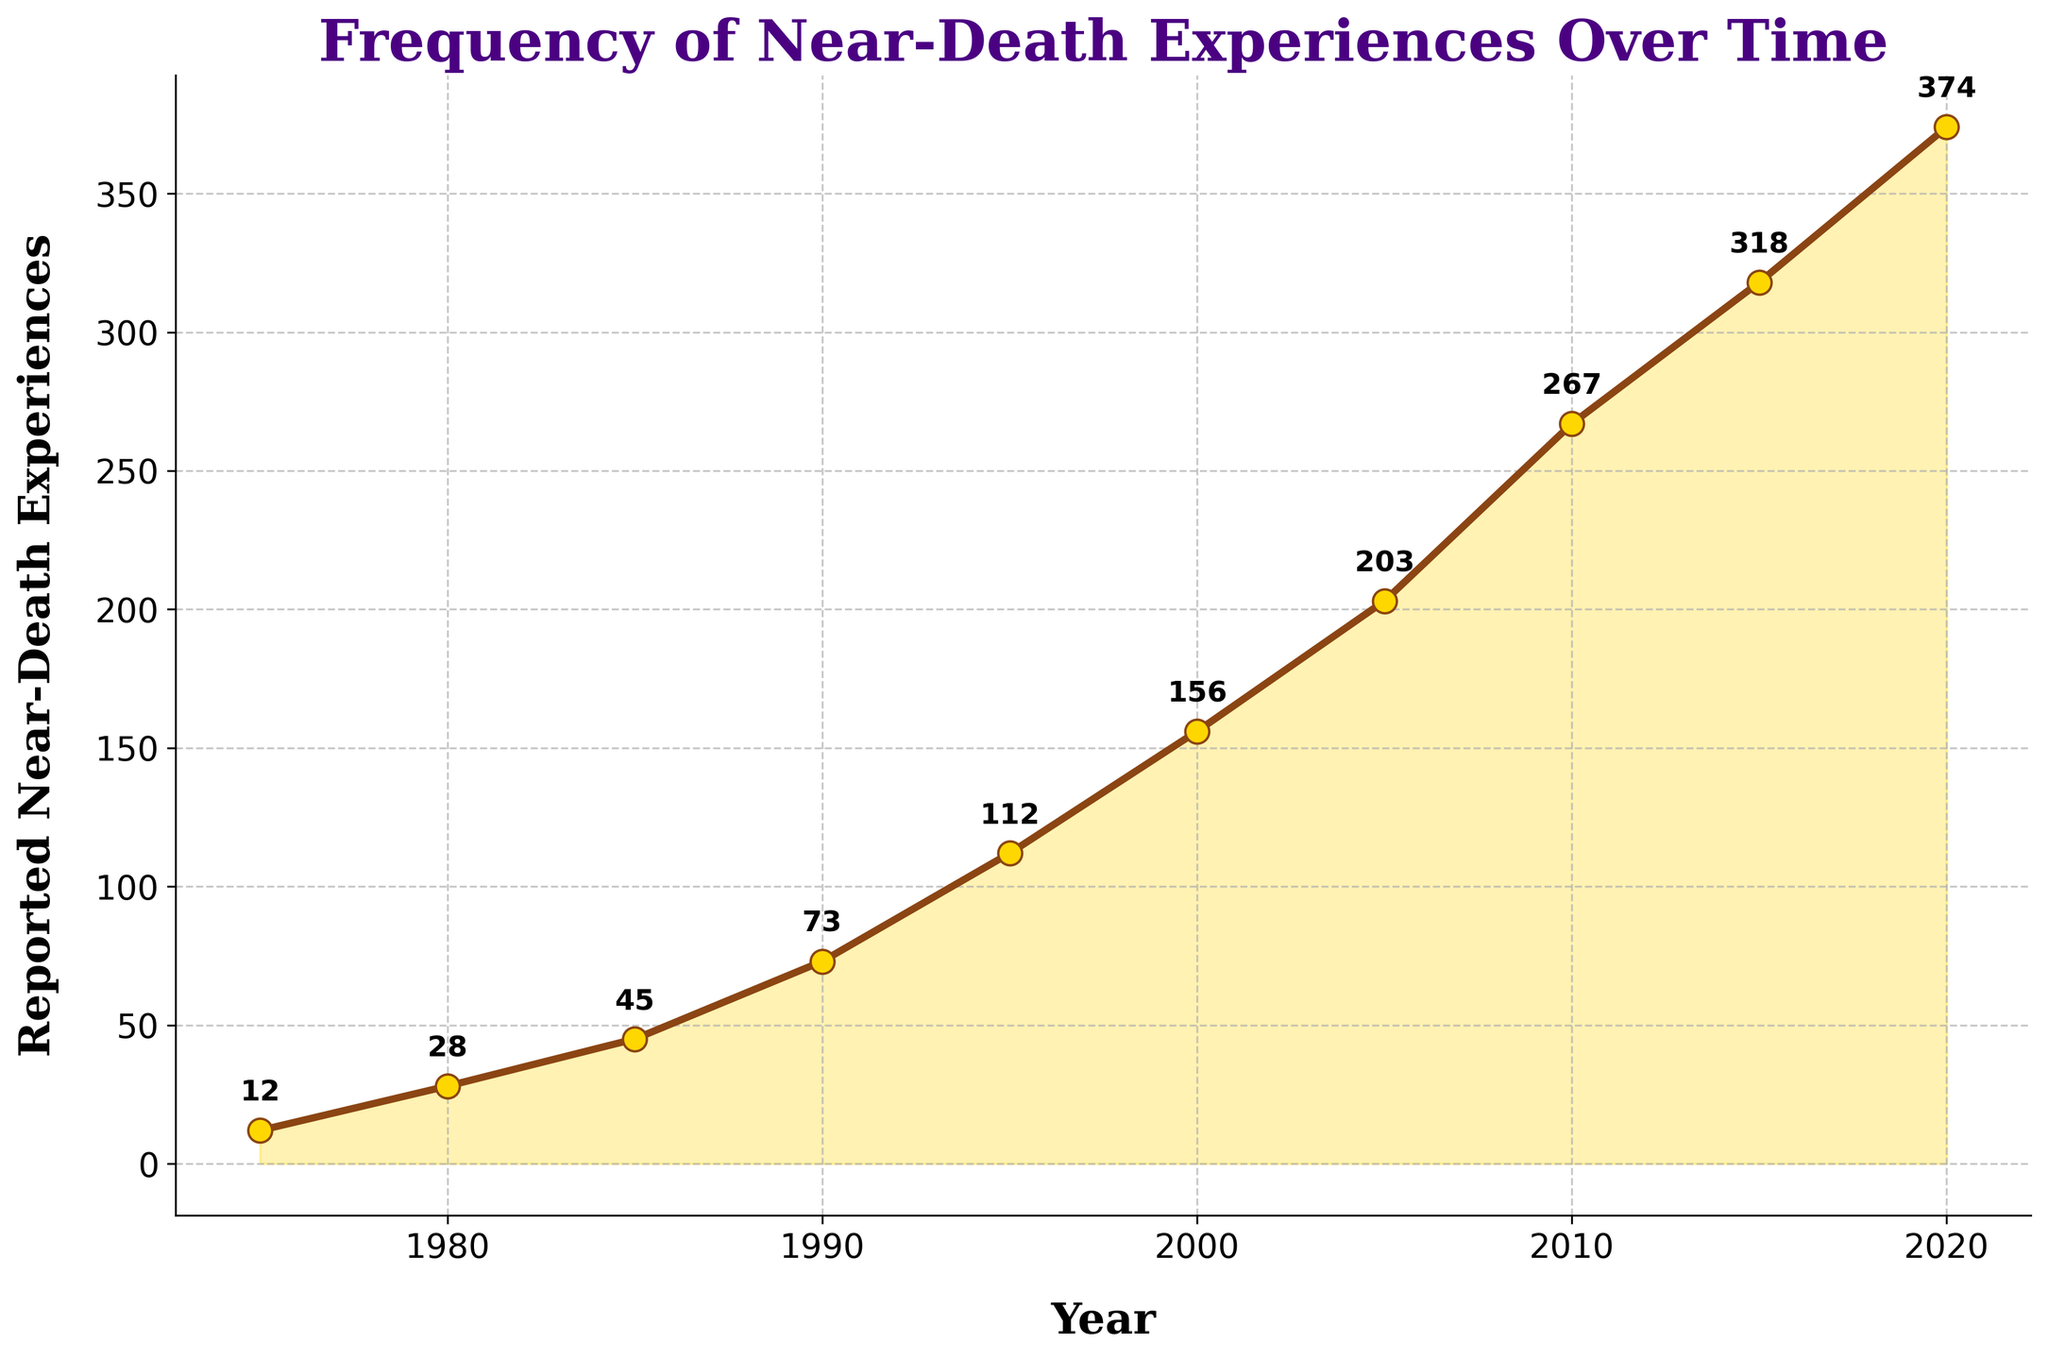What year saw the greatest increase in reported near-death experiences compared to the previous period? We can determine this by calculating the difference in reported experiences between each consecutive period. The differences are: 1975 to 1980 (16), 1980 to 1985 (17), 1985 to 1990 (28), 1990 to 1995 (39), 1995 to 2000 (44), 2000 to 2005 (47), 2005 to 2010 (64), 2010 to 2015 (51), 2015 to 2020 (56). The greatest increase is from 2005 to 2010 with an increase of 64.
Answer: 2010 What is the average number of reported near-death experiences per year from 1975 to 2020? Sum the total reported experiences and divide by the number of years. Total is 12 + 28 + 45 + 73 + 112 + 156 + 203 + 267 + 318 + 374 = 1588. There are 10 years, so the average is 1588 / 10.
Answer: 158.8 Between 2000 and 2020, in which period did the number of reported near-death experiences grow faster on average? From 2000 to 2005, the number increased by 47 (203 - 156), and this period covers 5 years, so the average annual increase is 47 / 5 = 9.4. From 2005 to 2010, it increased by 64, so the average annual increase is 64 / 5 = 12.8. From 2010 to 2015, it increased by 51, so the average annual increase is 51 / 5 = 10.2. Finally, from 2015 to 2020, the increase was 56, making the average annual increase 56 / 5 = 11.2. The period from 2005 to 2010 saw the fastest growth.
Answer: 2005-2010 How does the growth rate from 1980 to 1990 compare to the growth rate from 1990 to 2000? Calculate the yearly growth rates for each period and compare. From 1980 to 1990, grow is 73 - 28 = 45 over 10 years, so the average annual growth rate is 45 / 10 = 4.5. From 1990 to 2000, the growth is 156 - 73 = 83, so the average annual growth rate is 83 / 10 = 8.3. The growth rate from 1990 to 2000 is higher.
Answer: 1990-2000 What color is used to highlight the area under the line in the plot? The figure uses a distinct color to highlight the area under the line connected by the markers. The color used for this fill area is golden.
Answer: Golden What is the total number of reported near-death experiences from 1975 to 1995? Add up the reported numbers from 1975 to 1995. The sum is 12 + 28 + 45 + 73 + 112 = 270.
Answer: 270 Analyze the trend from 1975 to 2020. Does the frequency of reported near-death experiences show a steady increase, sporadic changes or a different pattern? By observing the line's continuity and upward progression, it is evident the frequency of near-death experiences shows a consistent and steady increase throughout the years, with no significant sporadic changes or erratic patterns seen.
Answer: Steady increase Which year marks the crossing of 100 reported near-death experiences for the first time? Identify the point on the plot where the reported experiences surpass 100. Based on the data, the year 1995 is when the number first exceeds 100, with 112 experiences reported.
Answer: 1995 When comparing the reported near-death experiences in 1975 and 2020, by how much did the number increase? Subtract the value for 1975 from the value for 2020. The difference is 374 - 12 = 362.
Answer: 362 